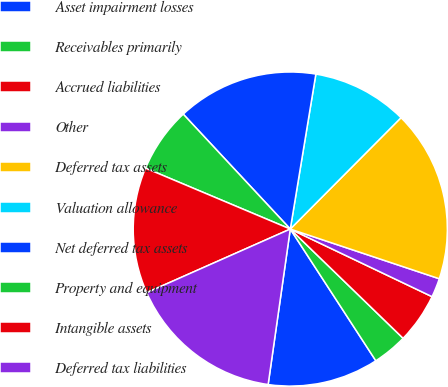<chart> <loc_0><loc_0><loc_500><loc_500><pie_chart><fcel>Asset impairment losses<fcel>Receivables primarily<fcel>Accrued liabilities<fcel>Other<fcel>Deferred tax assets<fcel>Valuation allowance<fcel>Net deferred tax assets<fcel>Property and equipment<fcel>Intangible assets<fcel>Deferred tax liabilities<nl><fcel>11.42%<fcel>3.59%<fcel>5.16%<fcel>1.96%<fcel>17.67%<fcel>9.85%<fcel>14.54%<fcel>6.72%<fcel>12.98%<fcel>16.11%<nl></chart> 